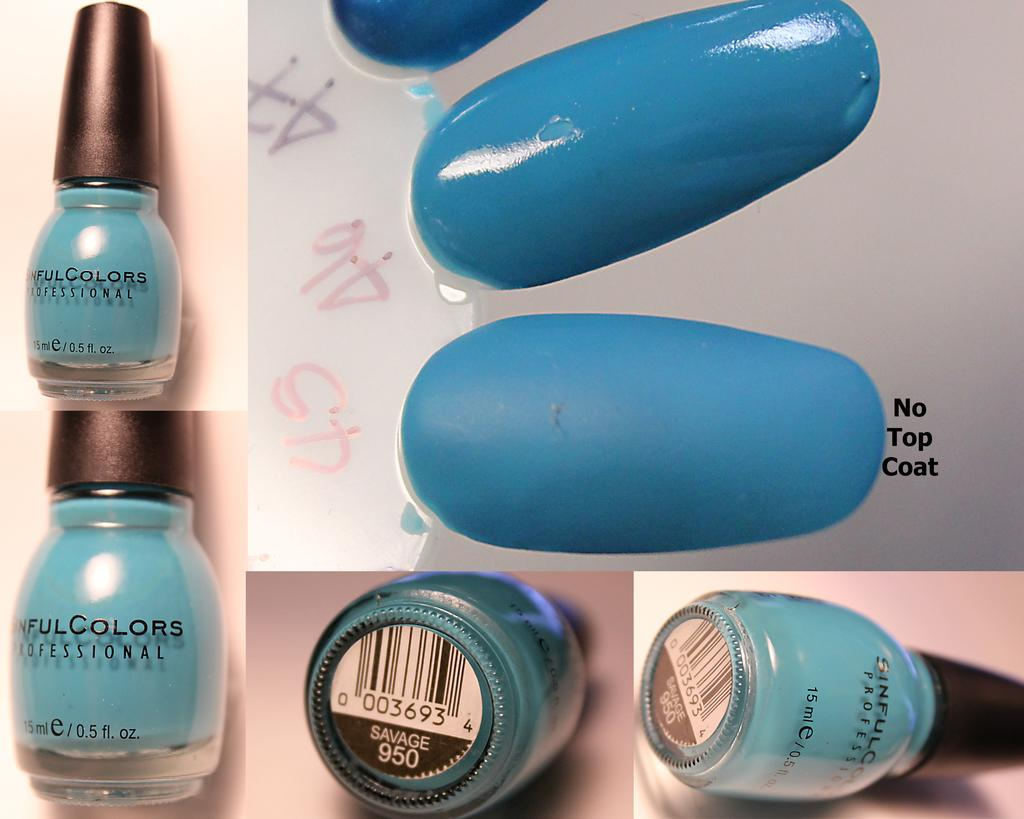<image>
Give a short and clear explanation of the subsequent image. A blue bottle of nail polish by sinful colors on the front. 